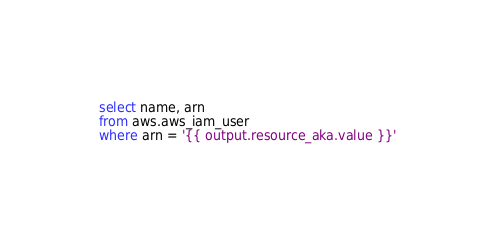Convert code to text. <code><loc_0><loc_0><loc_500><loc_500><_SQL_>select name, arn
from aws.aws_iam_user
where arn = '{{ output.resource_aka.value }}'
</code> 